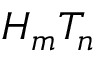Convert formula to latex. <formula><loc_0><loc_0><loc_500><loc_500>H _ { m } T _ { n }</formula> 